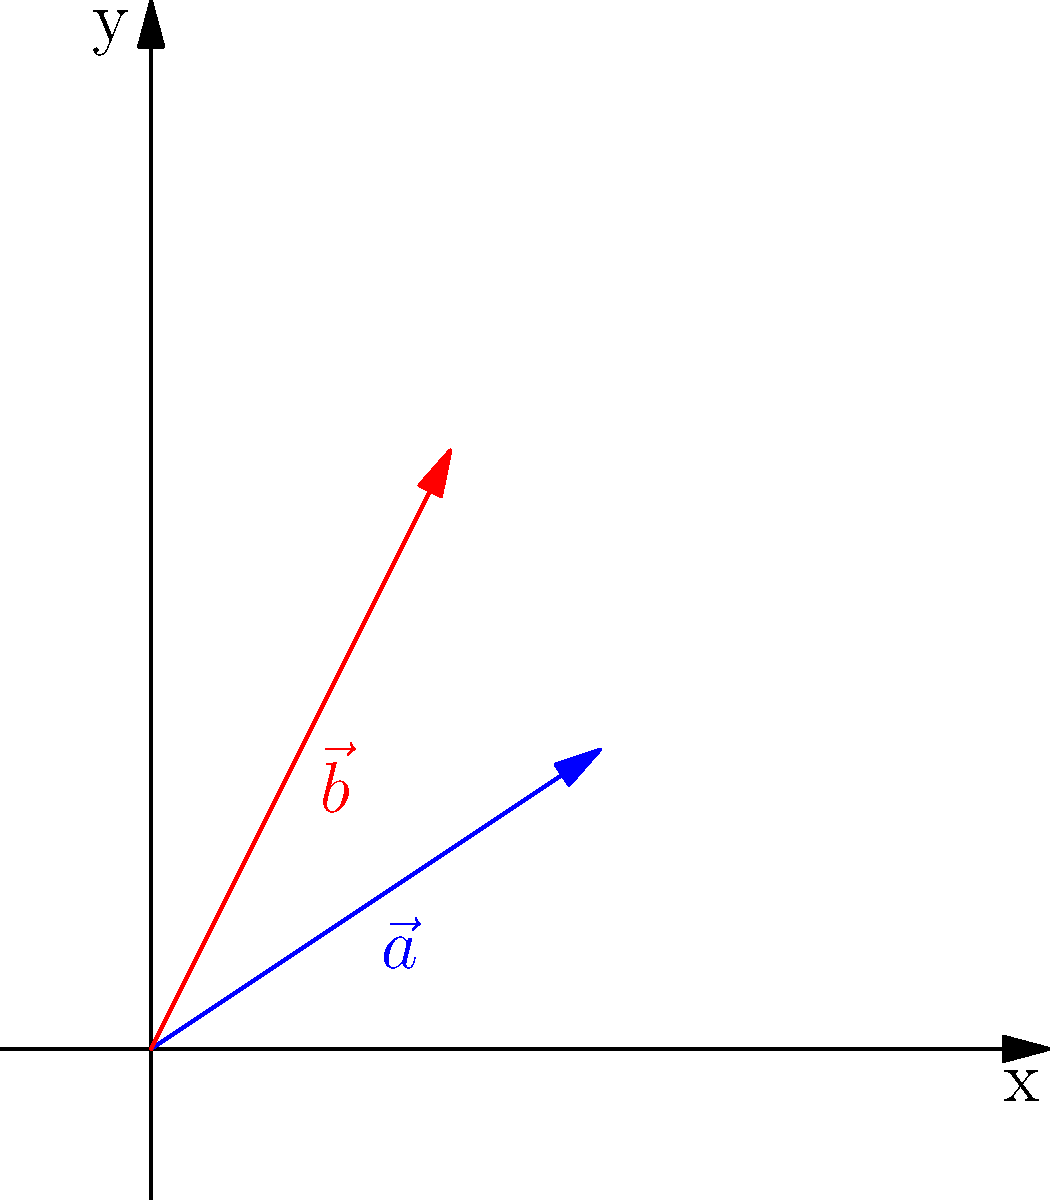As a livestock management expert, you need to determine the optimal placement of a new pen in relation to two existing pens. The vector $\vec{a} = (3, 2)$ represents the distance and direction from the origin to the first pen, and $\vec{b} = (2, 4)$ represents the distance and direction from the origin to the second pen. If the new pen should be placed at a location that is the sum of these two vectors, what are the coordinates of the new pen's location? To solve this problem, we need to use vector addition. The new pen's location will be represented by the vector $\vec{c}$, which is the sum of vectors $\vec{a}$ and $\vec{b}$.

Step 1: Identify the components of each vector
$\vec{a} = (3, 2)$
$\vec{b} = (2, 4)$

Step 2: Add the corresponding components of the vectors
$\vec{c} = \vec{a} + \vec{b}$
$\vec{c}_x = a_x + b_x = 3 + 2 = 5$
$\vec{c}_y = a_y + b_y = 2 + 4 = 6$

Step 3: Express the result as a vector
$\vec{c} = (5, 6)$

Therefore, the coordinates of the new pen's location are (5, 6).
Answer: (5, 6) 